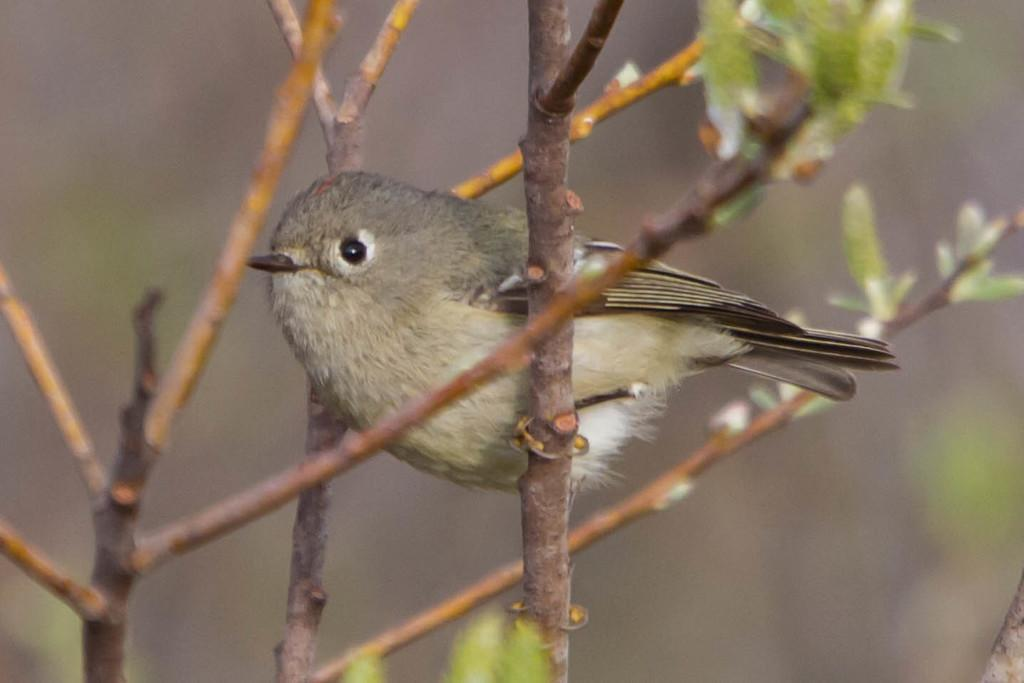What type of vegetation can be seen in the image? There are green color leaves in the image. What else is present in the image besides the leaves? There are stems in the image. Are there any animals visible in the image? Yes, there is a bird in the image. How would you describe the overall quality of the image? The image is slightly blurry. What type of ink is being used by the bird in the image? There is no ink present in the image, and the bird is not using any ink. 